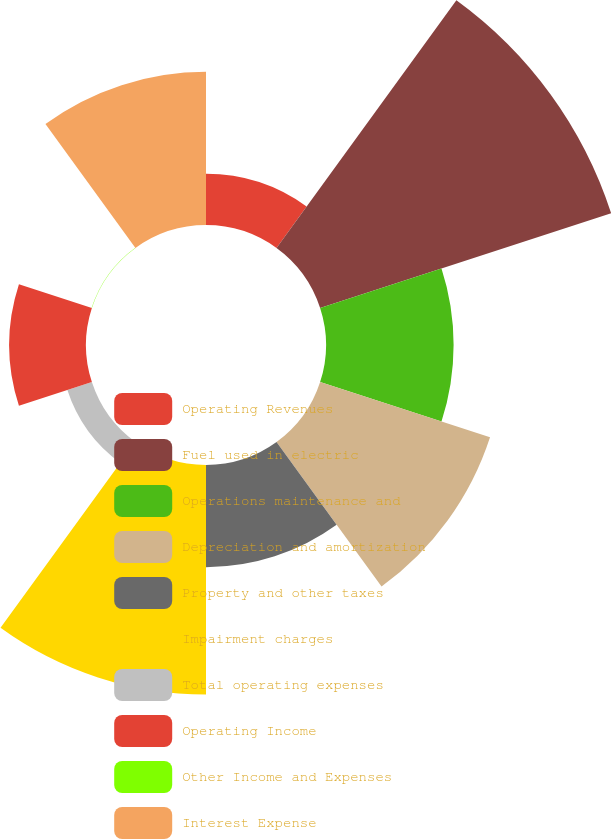<chart> <loc_0><loc_0><loc_500><loc_500><pie_chart><fcel>Operating Revenues<fcel>Fuel used in electric<fcel>Operations maintenance and<fcel>Depreciation and amortization<fcel>Property and other taxes<fcel>Impairment charges<fcel>Total operating expenses<fcel>Operating Income<fcel>Other Income and Expenses<fcel>Interest Expense<nl><fcel>4.09%<fcel>24.46%<fcel>10.2%<fcel>14.28%<fcel>8.17%<fcel>18.35%<fcel>2.06%<fcel>6.13%<fcel>0.02%<fcel>12.24%<nl></chart> 